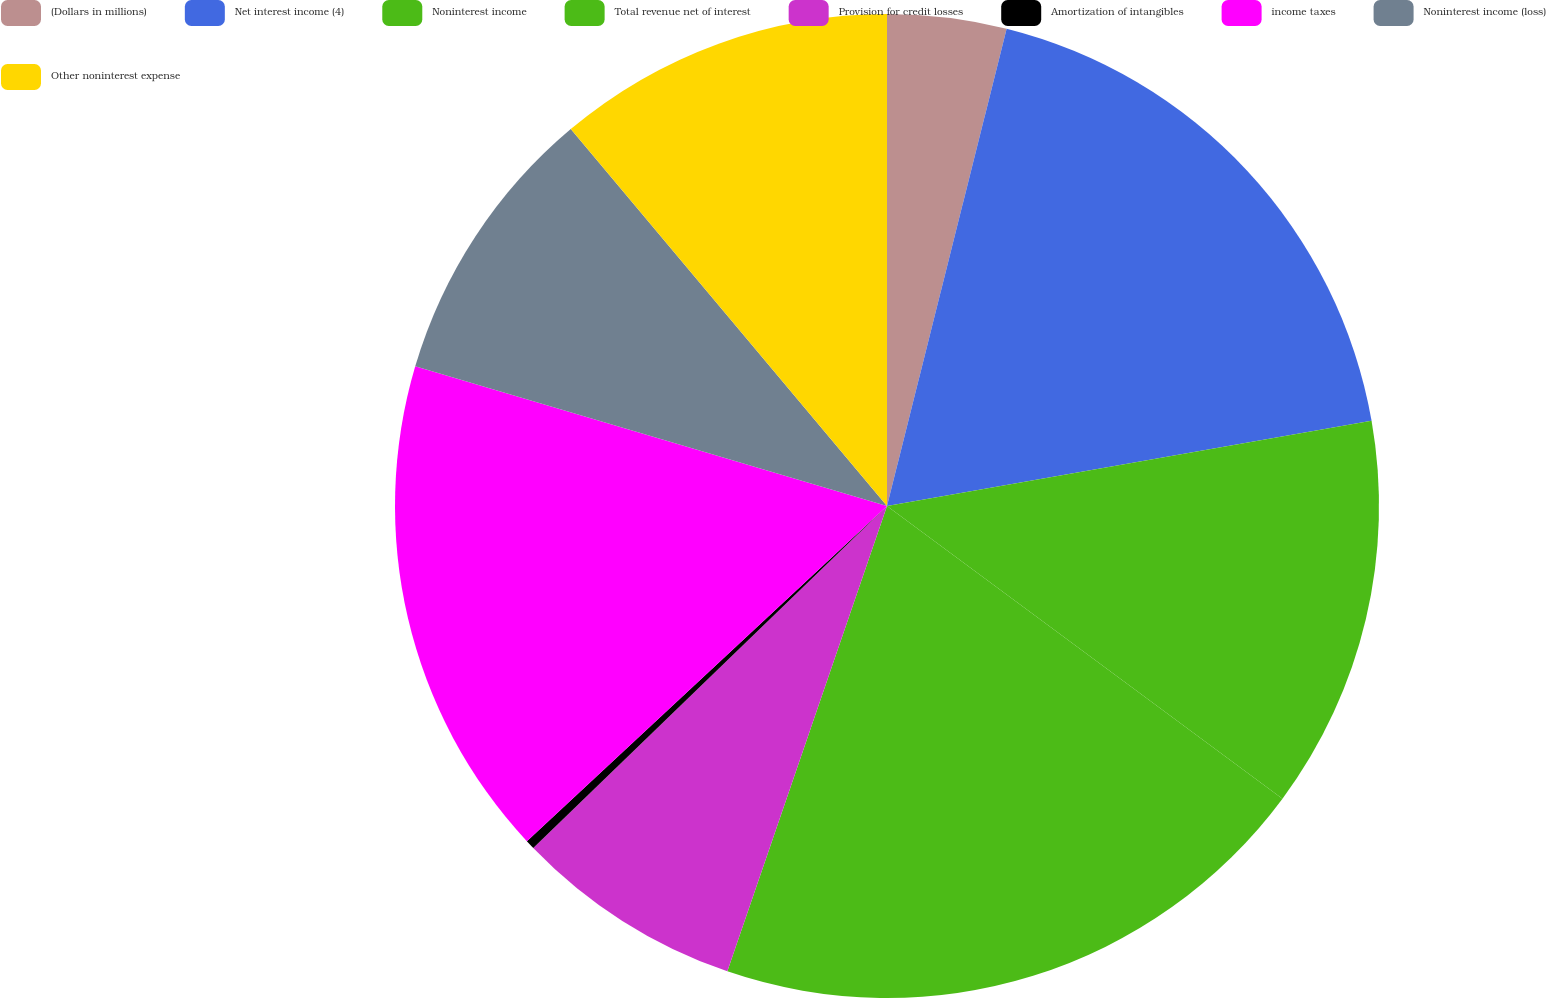Convert chart. <chart><loc_0><loc_0><loc_500><loc_500><pie_chart><fcel>(Dollars in millions)<fcel>Net interest income (4)<fcel>Noninterest income<fcel>Total revenue net of interest<fcel>Provision for credit losses<fcel>Amortization of intangibles<fcel>income taxes<fcel>Noninterest income (loss)<fcel>Other noninterest expense<nl><fcel>3.91%<fcel>18.32%<fcel>12.91%<fcel>20.12%<fcel>7.51%<fcel>0.3%<fcel>16.51%<fcel>9.31%<fcel>11.11%<nl></chart> 